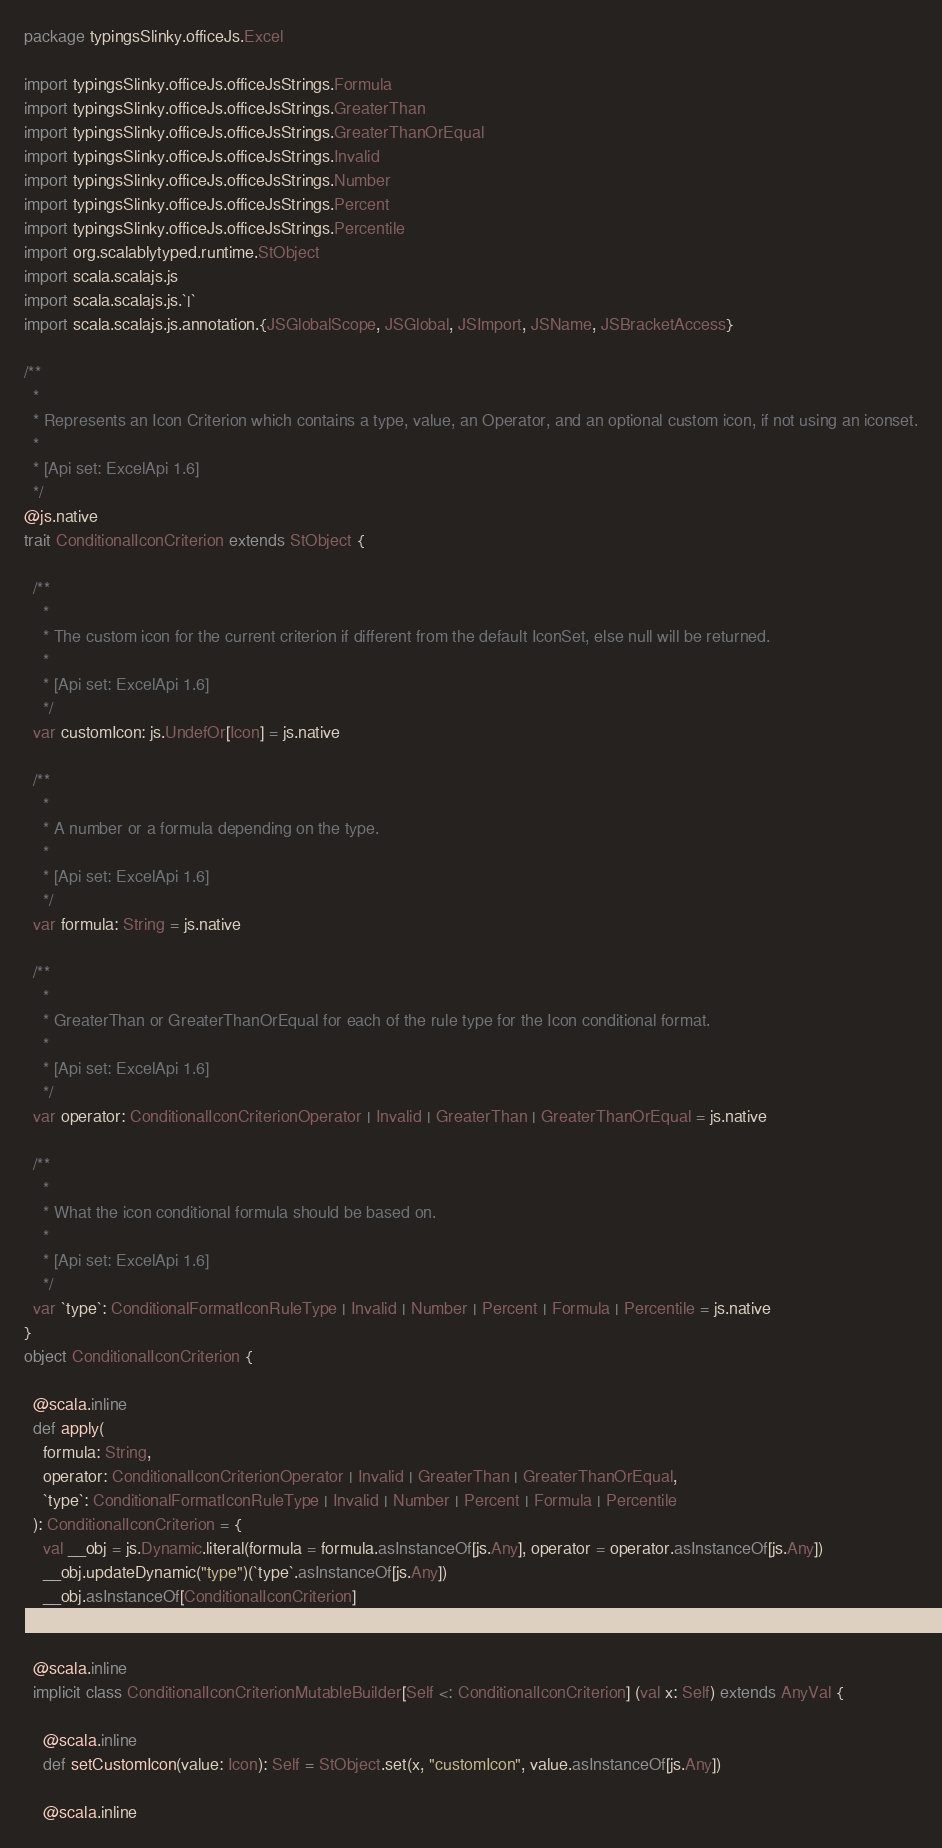<code> <loc_0><loc_0><loc_500><loc_500><_Scala_>package typingsSlinky.officeJs.Excel

import typingsSlinky.officeJs.officeJsStrings.Formula
import typingsSlinky.officeJs.officeJsStrings.GreaterThan
import typingsSlinky.officeJs.officeJsStrings.GreaterThanOrEqual
import typingsSlinky.officeJs.officeJsStrings.Invalid
import typingsSlinky.officeJs.officeJsStrings.Number
import typingsSlinky.officeJs.officeJsStrings.Percent
import typingsSlinky.officeJs.officeJsStrings.Percentile
import org.scalablytyped.runtime.StObject
import scala.scalajs.js
import scala.scalajs.js.`|`
import scala.scalajs.js.annotation.{JSGlobalScope, JSGlobal, JSImport, JSName, JSBracketAccess}

/**
  *
  * Represents an Icon Criterion which contains a type, value, an Operator, and an optional custom icon, if not using an iconset.
  *
  * [Api set: ExcelApi 1.6]
  */
@js.native
trait ConditionalIconCriterion extends StObject {
  
  /**
    *
    * The custom icon for the current criterion if different from the default IconSet, else null will be returned.
    *
    * [Api set: ExcelApi 1.6]
    */
  var customIcon: js.UndefOr[Icon] = js.native
  
  /**
    *
    * A number or a formula depending on the type.
    *
    * [Api set: ExcelApi 1.6]
    */
  var formula: String = js.native
  
  /**
    *
    * GreaterThan or GreaterThanOrEqual for each of the rule type for the Icon conditional format.
    *
    * [Api set: ExcelApi 1.6]
    */
  var operator: ConditionalIconCriterionOperator | Invalid | GreaterThan | GreaterThanOrEqual = js.native
  
  /**
    *
    * What the icon conditional formula should be based on.
    *
    * [Api set: ExcelApi 1.6]
    */
  var `type`: ConditionalFormatIconRuleType | Invalid | Number | Percent | Formula | Percentile = js.native
}
object ConditionalIconCriterion {
  
  @scala.inline
  def apply(
    formula: String,
    operator: ConditionalIconCriterionOperator | Invalid | GreaterThan | GreaterThanOrEqual,
    `type`: ConditionalFormatIconRuleType | Invalid | Number | Percent | Formula | Percentile
  ): ConditionalIconCriterion = {
    val __obj = js.Dynamic.literal(formula = formula.asInstanceOf[js.Any], operator = operator.asInstanceOf[js.Any])
    __obj.updateDynamic("type")(`type`.asInstanceOf[js.Any])
    __obj.asInstanceOf[ConditionalIconCriterion]
  }
  
  @scala.inline
  implicit class ConditionalIconCriterionMutableBuilder[Self <: ConditionalIconCriterion] (val x: Self) extends AnyVal {
    
    @scala.inline
    def setCustomIcon(value: Icon): Self = StObject.set(x, "customIcon", value.asInstanceOf[js.Any])
    
    @scala.inline</code> 